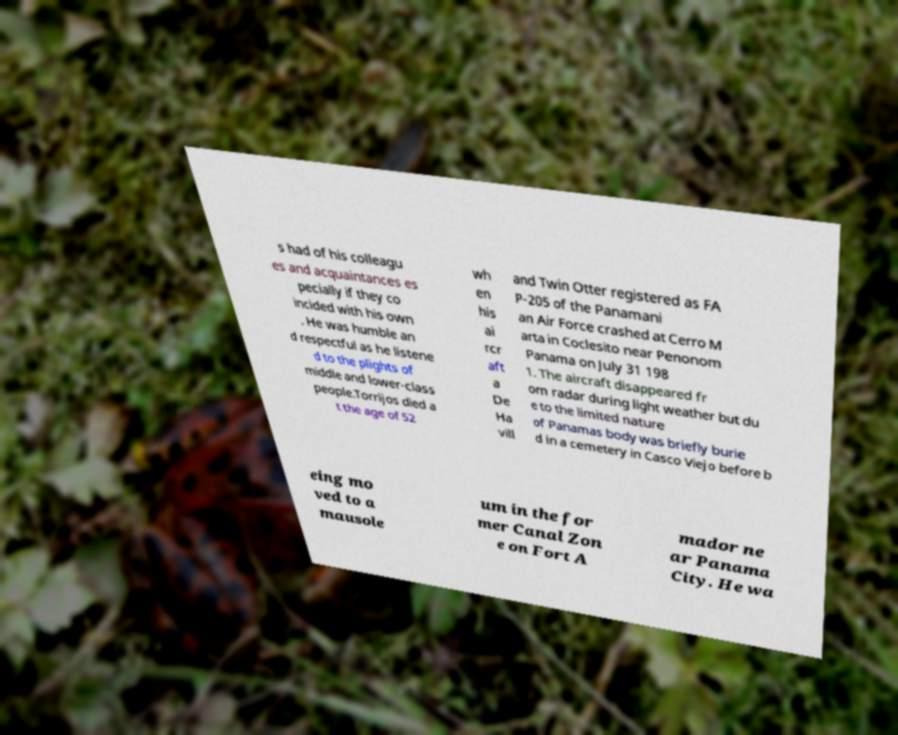Can you accurately transcribe the text from the provided image for me? s had of his colleagu es and acquaintances es pecially if they co incided with his own . He was humble an d respectful as he listene d to the plights of middle and lower-class people.Torrijos died a t the age of 52 wh en his ai rcr aft a De Ha vill and Twin Otter registered as FA P-205 of the Panamani an Air Force crashed at Cerro M arta in Coclesito near Penonom Panama on July 31 198 1. The aircraft disappeared fr om radar during light weather but du e to the limited nature of Panamas body was briefly burie d in a cemetery in Casco Viejo before b eing mo ved to a mausole um in the for mer Canal Zon e on Fort A mador ne ar Panama City. He wa 